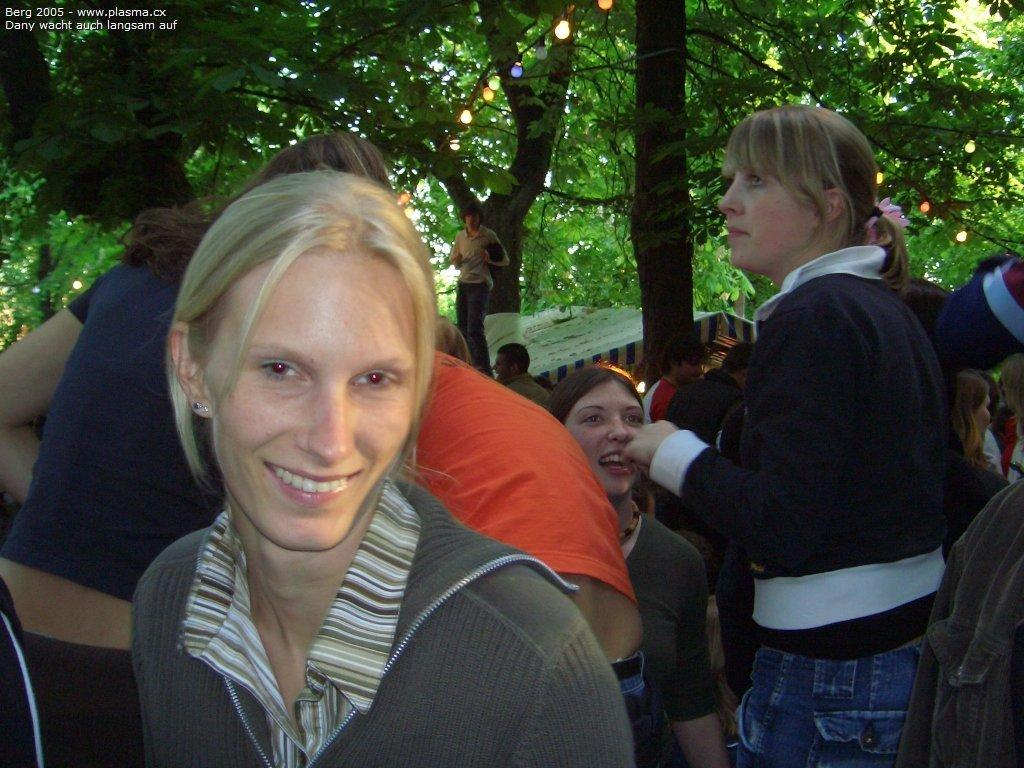What is happening in the middle of the image? There are women standing in the middle of the image. What is the facial expression of the women? The women are smiling. What can be seen in the background behind the women? There are trees and tents visible behind the women. What type of produce is being harvested by the women in the image? There is no produce or harvesting activity visible in the image; the women are simply standing and smiling. 